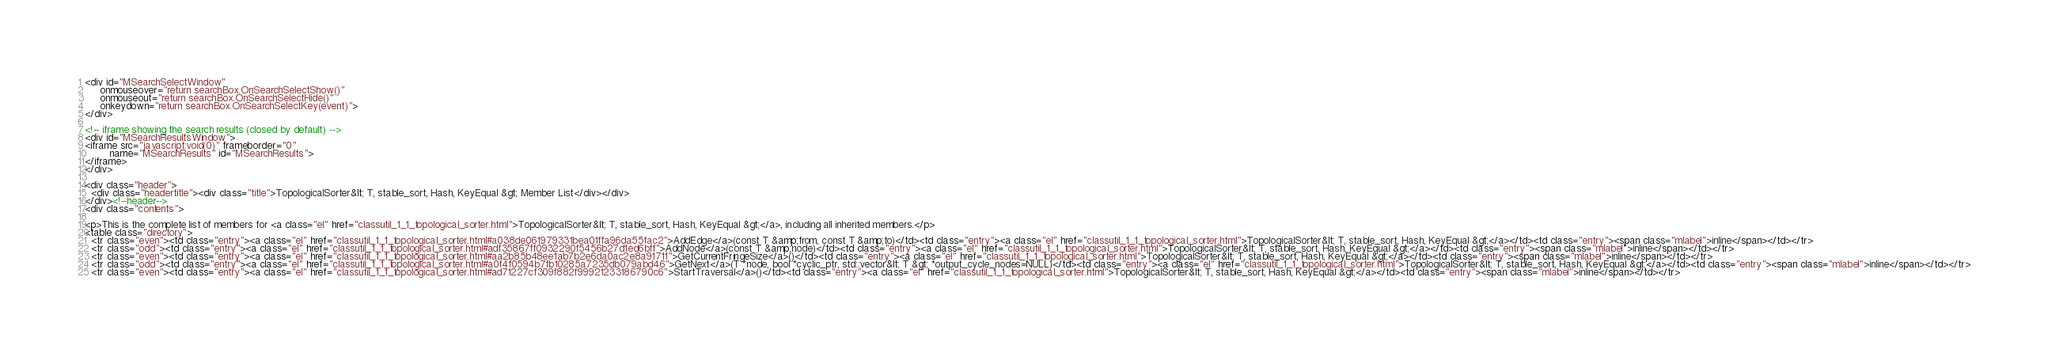<code> <loc_0><loc_0><loc_500><loc_500><_HTML_><div id="MSearchSelectWindow"
     onmouseover="return searchBox.OnSearchSelectShow()"
     onmouseout="return searchBox.OnSearchSelectHide()"
     onkeydown="return searchBox.OnSearchSelectKey(event)">
</div>

<!-- iframe showing the search results (closed by default) -->
<div id="MSearchResultsWindow">
<iframe src="javascript:void(0)" frameborder="0" 
        name="MSearchResults" id="MSearchResults">
</iframe>
</div>

<div class="header">
  <div class="headertitle"><div class="title">TopologicalSorter&lt; T, stable_sort, Hash, KeyEqual &gt; Member List</div></div>
</div><!--header-->
<div class="contents">

<p>This is the complete list of members for <a class="el" href="classutil_1_1_topological_sorter.html">TopologicalSorter&lt; T, stable_sort, Hash, KeyEqual &gt;</a>, including all inherited members.</p>
<table class="directory">
  <tr class="even"><td class="entry"><a class="el" href="classutil_1_1_topological_sorter.html#a038de061979331bea01ffa96da55fac2">AddEdge</a>(const T &amp;from, const T &amp;to)</td><td class="entry"><a class="el" href="classutil_1_1_topological_sorter.html">TopologicalSorter&lt; T, stable_sort, Hash, KeyEqual &gt;</a></td><td class="entry"><span class="mlabel">inline</span></td></tr>
  <tr class="odd"><td class="entry"><a class="el" href="classutil_1_1_topological_sorter.html#adf35867ff0932290f5456b27d1ed6bff">AddNode</a>(const T &amp;node)</td><td class="entry"><a class="el" href="classutil_1_1_topological_sorter.html">TopologicalSorter&lt; T, stable_sort, Hash, KeyEqual &gt;</a></td><td class="entry"><span class="mlabel">inline</span></td></tr>
  <tr class="even"><td class="entry"><a class="el" href="classutil_1_1_topological_sorter.html#aa2b85b48ee1ab7b2e6da0ac2e8a91711">GetCurrentFringeSize</a>()</td><td class="entry"><a class="el" href="classutil_1_1_topological_sorter.html">TopologicalSorter&lt; T, stable_sort, Hash, KeyEqual &gt;</a></td><td class="entry"><span class="mlabel">inline</span></td></tr>
  <tr class="odd"><td class="entry"><a class="el" href="classutil_1_1_topological_sorter.html#a0f4f0594b7fb10285a7235db079abd46">GetNext</a>(T *node, bool *cyclic_ptr, std::vector&lt; T &gt; *output_cycle_nodes=NULL)</td><td class="entry"><a class="el" href="classutil_1_1_topological_sorter.html">TopologicalSorter&lt; T, stable_sort, Hash, KeyEqual &gt;</a></td><td class="entry"><span class="mlabel">inline</span></td></tr>
  <tr class="even"><td class="entry"><a class="el" href="classutil_1_1_topological_sorter.html#ad71227cf309f882f99921233186790c6">StartTraversal</a>()</td><td class="entry"><a class="el" href="classutil_1_1_topological_sorter.html">TopologicalSorter&lt; T, stable_sort, Hash, KeyEqual &gt;</a></td><td class="entry"><span class="mlabel">inline</span></td></tr></code> 